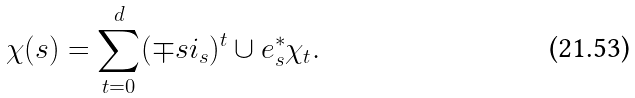Convert formula to latex. <formula><loc_0><loc_0><loc_500><loc_500>\chi ( s ) = \sum _ { t = 0 } ^ { d } ( \mp s i _ { s } ) ^ { t } \cup e _ { s } ^ { * } \chi _ { t } .</formula> 